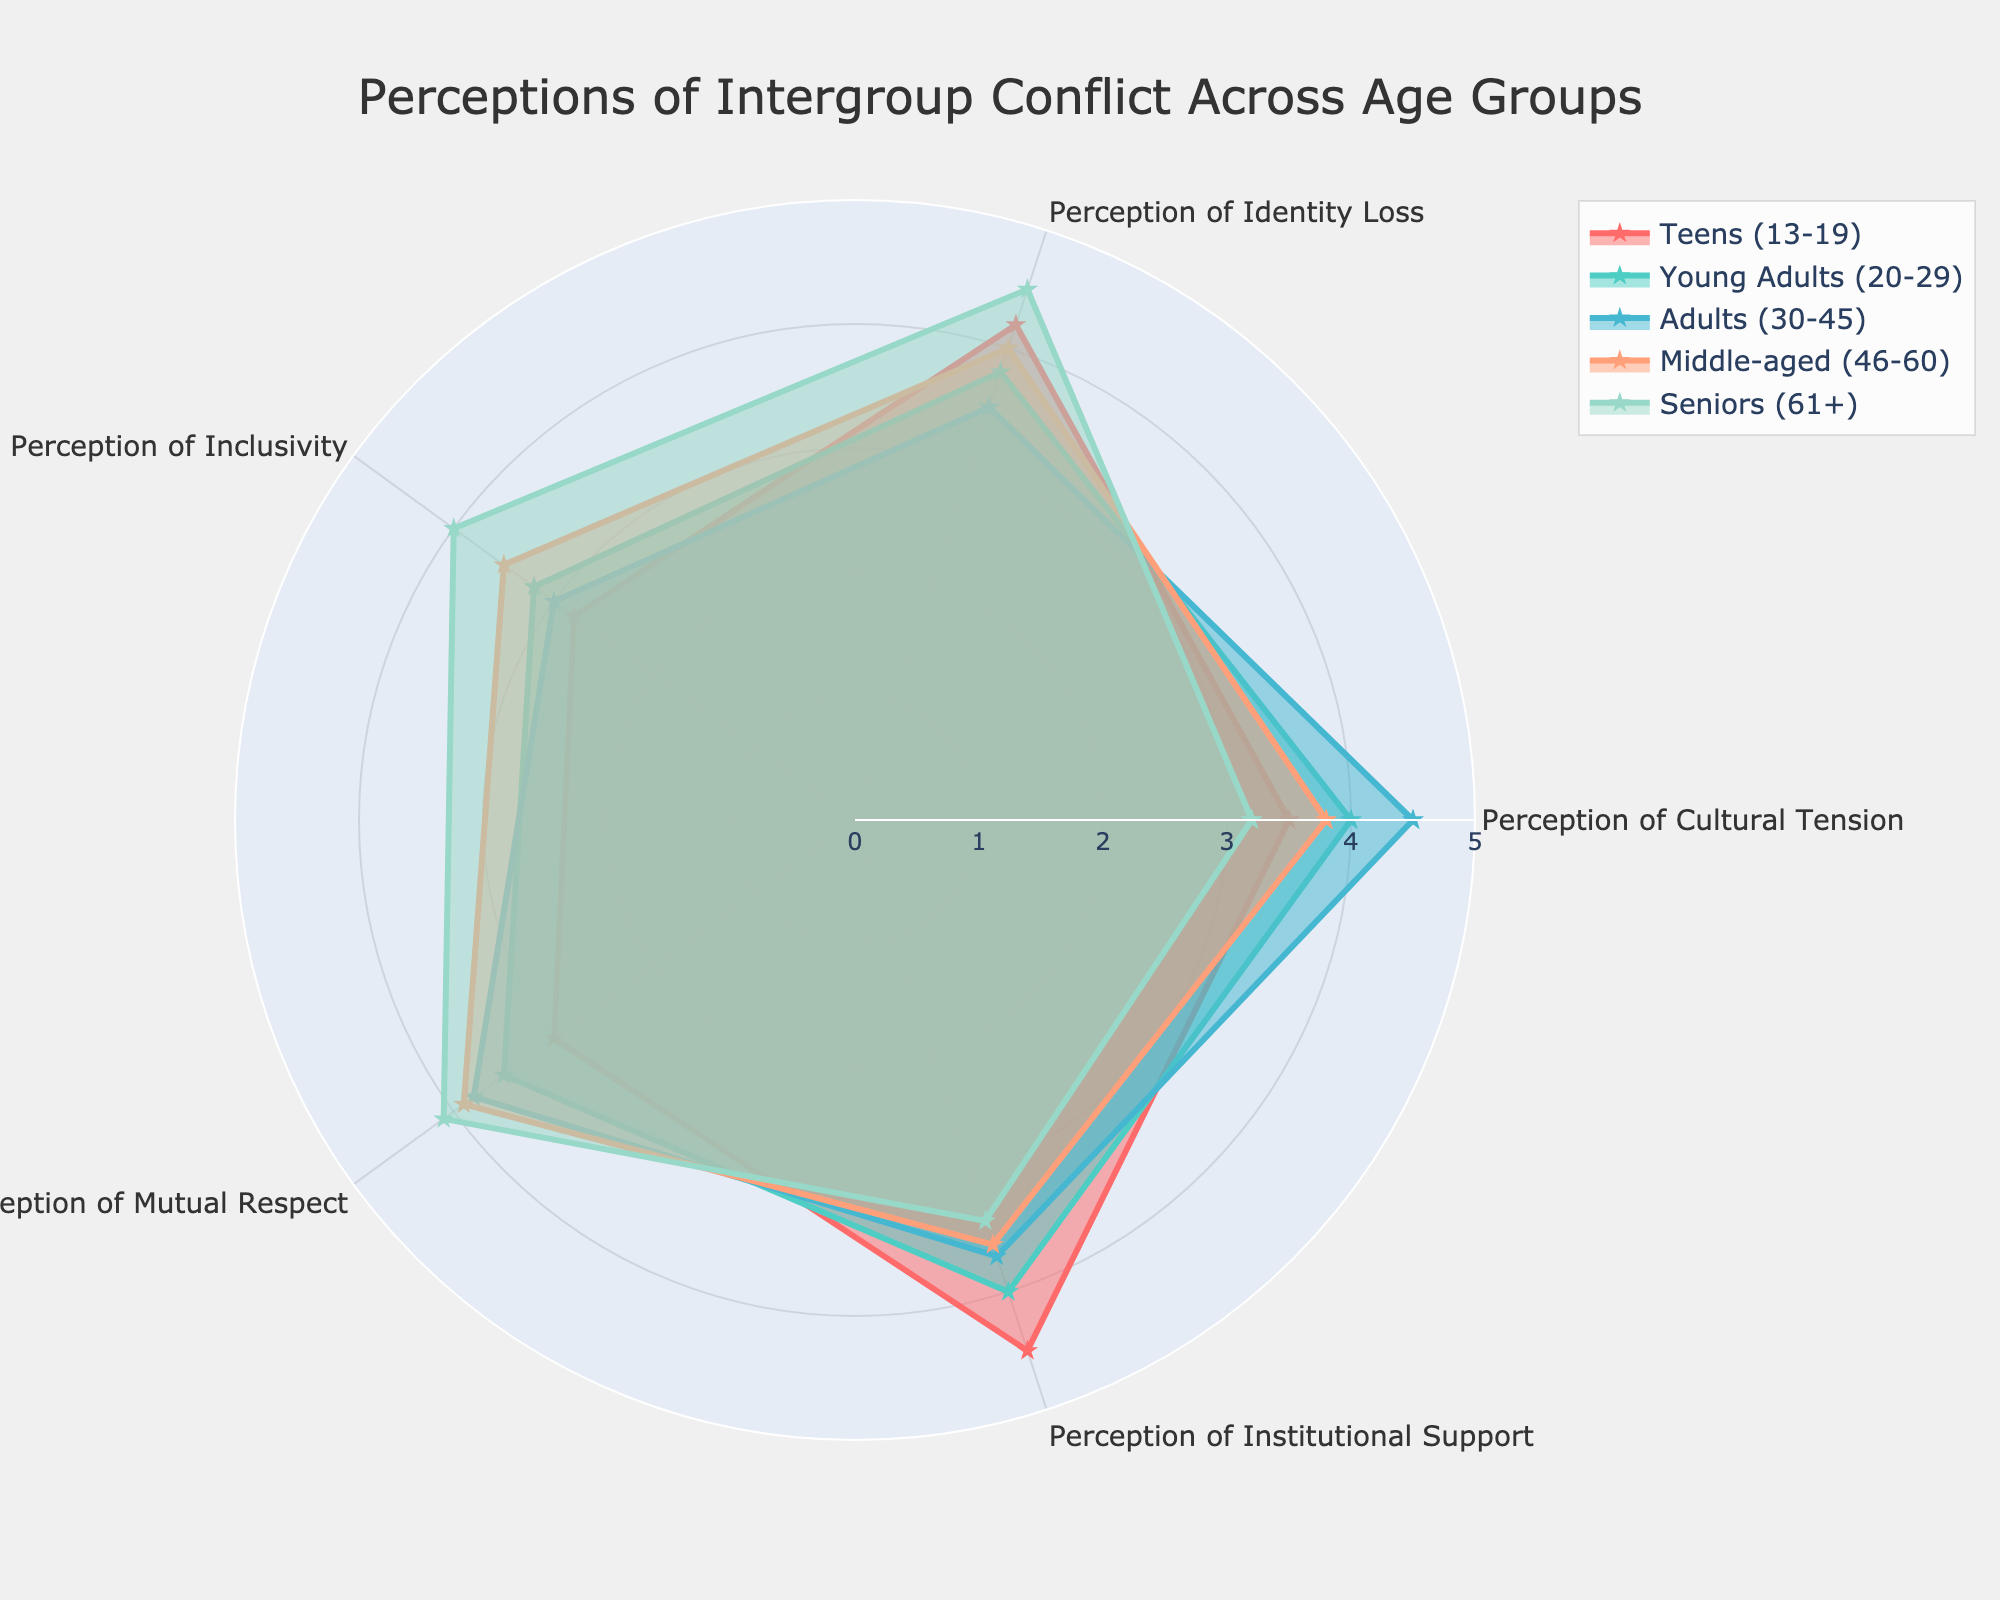What is the highest perceived cultural tension among the age groups? Upon examining the radar chart, the "Adults (30-45)" group has the highest value for the "Perception of Cultural Tension" at 4.5.
Answer: 4.5 Which age group perceives the highest level of institutional support? From the radar chart, the "Teens (13-19)" group has the highest value for "Perception of Institutional Support" at 4.5.
Answer: Teens (13-19) How do perceptions of inclusivity compare between "Young Adults (20-29)" and "Seniors (61+)"? The radar chart shows that the "Young Adults (20-29)" have a value of 3.2, and "Seniors (61+)" have a value of 4.0 for the "Perception of Inclusivity". Therefore, "Seniors (61+)" have a higher perception of inclusivity.
Answer: Seniors (61+) Which perception category shows the largest difference between "Teens (13-19)" and "Seniors (61+)"? Comparing each category, "Perception of Inclusivity" shows the largest difference: "Teens (13-19)" have a value of 2.8 while "Seniors (61+)" have 4.0, giving a difference of 1.2.
Answer: Perception of Inclusivity Are there any categories where all age groups have a perception greater than 3.0? Analyzing the values in each category from the radar chart, "Perception of Institutional Support" has values greater than 3.0 for all age groups: 4.5, 4.0, 3.7, 3.6, and 3.4.
Answer: Perception of Institutional Support What is the average perception of mutual respect across all age groups? Summing the mutual respect perceptions and dividing by the number of groups: (3.0 + 3.5 + 3.8 + 3.9 + 4.1) / 5 = 3.66
Answer: 3.66 Between "Adults (30-45)" and "Middle-aged (46-60)", which age group has a higher perception of identity loss? The radar chart indicates "Adults (30-45)" have a value of 3.5, whereas "Middle-aged (46-60)" have a value of 4.0 for "Perception of Identity Loss". Hence, "Middle-aged (46-60)" have a higher perception of identity loss.
Answer: Middle-aged (46-60) What are the two perceptions where "Young Adults (20-29)" score highest? By examining each perception, "Young Adults (20-29)" score highest in "Perception of Cultural Tension" and "Perception of Institutional Support" with values of 4.0 each.
Answer: Perception of Cultural Tension and Perception of Institutional Support Do "Teens (13-19)" perceive higher identity loss compared to their perception of inclusivity? According to the radar chart, "Teens (13-19)" have a value of 4.2 for "Perception of Identity Loss" and 2.8 for "Perception of Inclusivity", indicating a higher perception of identity loss.
Answer: Yes 